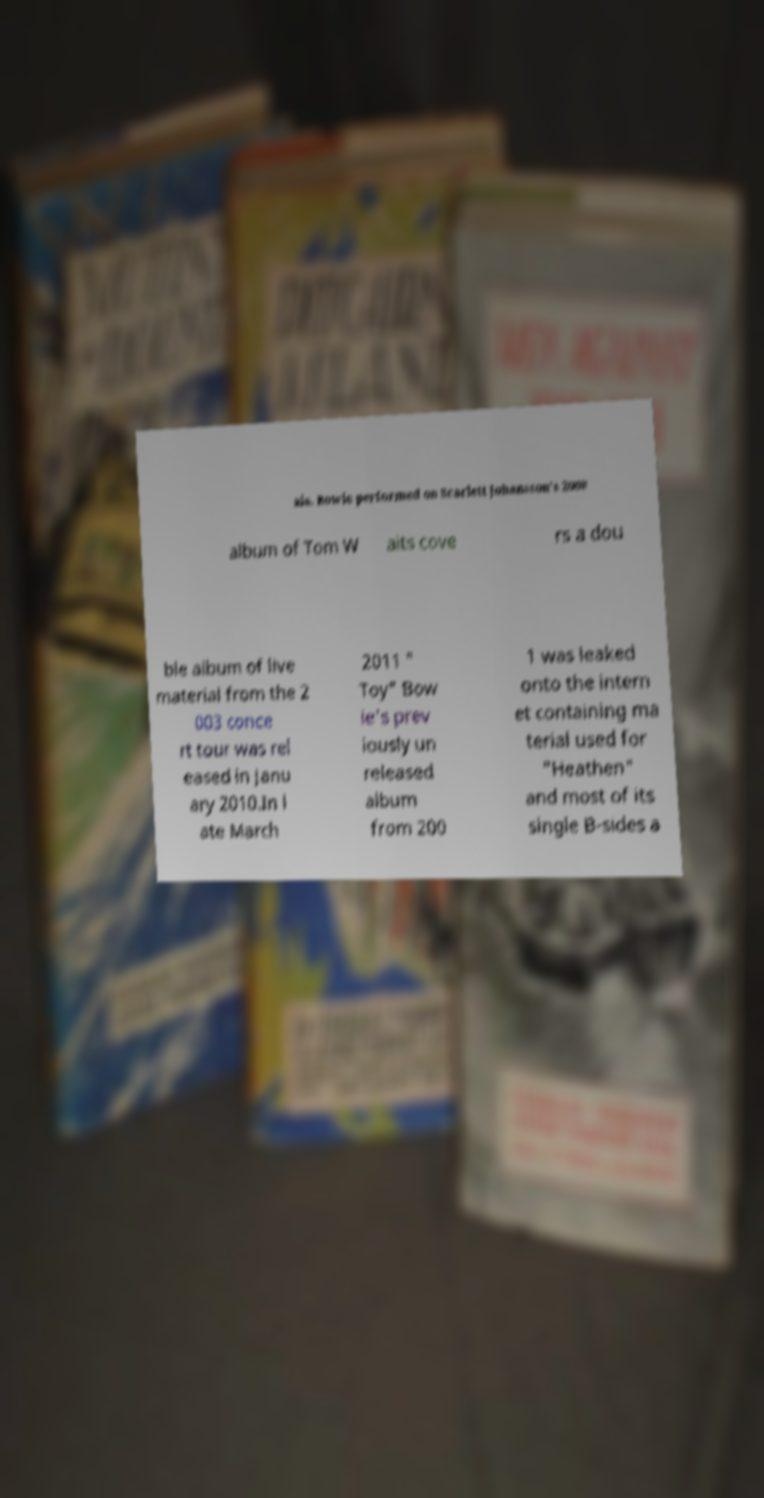Can you read and provide the text displayed in the image?This photo seems to have some interesting text. Can you extract and type it out for me? ais. Bowie performed on Scarlett Johansson's 2008 album of Tom W aits cove rs a dou ble album of live material from the 2 003 conce rt tour was rel eased in Janu ary 2010.In l ate March 2011 " Toy" Bow ie's prev iously un released album from 200 1 was leaked onto the intern et containing ma terial used for "Heathen" and most of its single B-sides a 